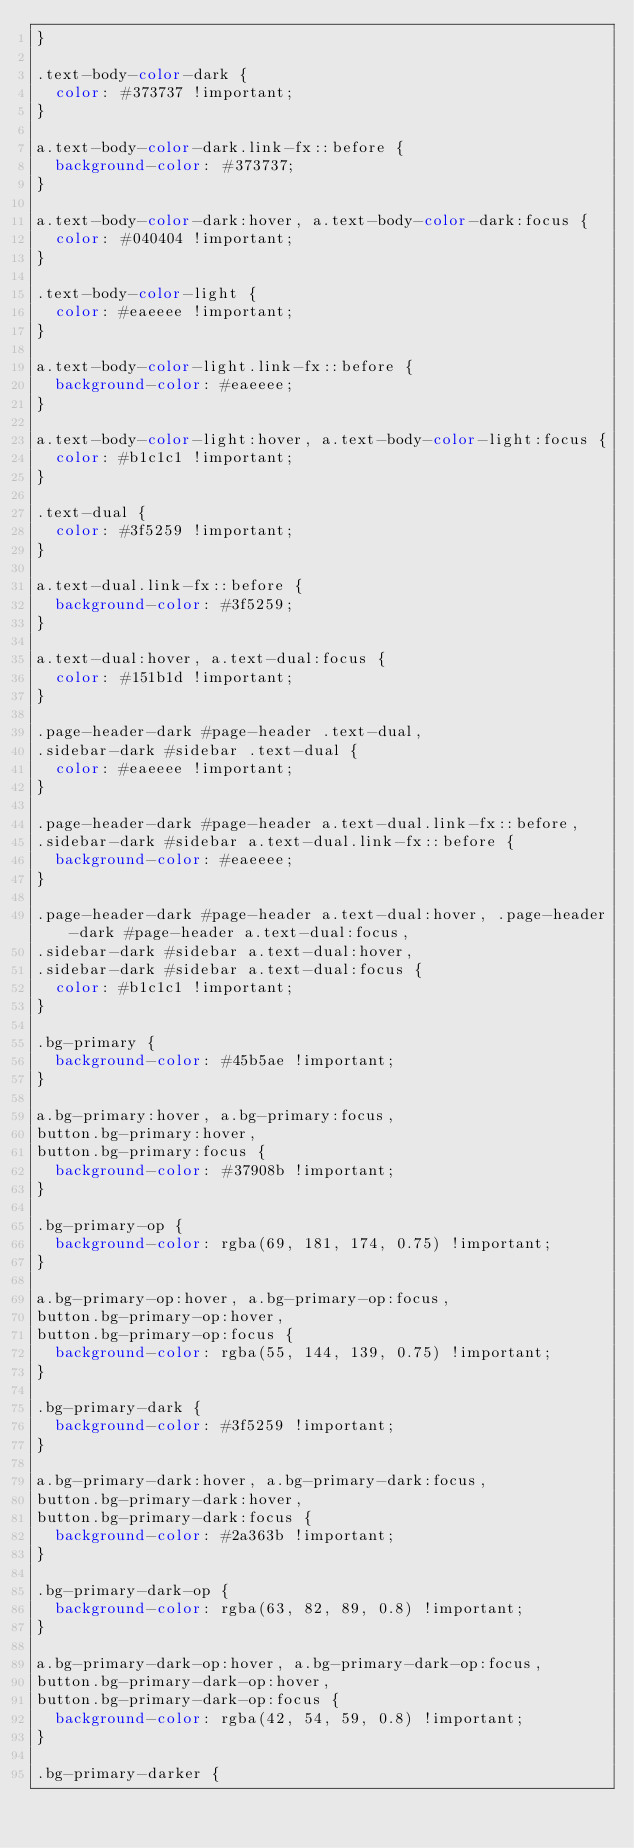Convert code to text. <code><loc_0><loc_0><loc_500><loc_500><_CSS_>}

.text-body-color-dark {
  color: #373737 !important;
}

a.text-body-color-dark.link-fx::before {
  background-color: #373737;
}

a.text-body-color-dark:hover, a.text-body-color-dark:focus {
  color: #040404 !important;
}

.text-body-color-light {
  color: #eaeeee !important;
}

a.text-body-color-light.link-fx::before {
  background-color: #eaeeee;
}

a.text-body-color-light:hover, a.text-body-color-light:focus {
  color: #b1c1c1 !important;
}

.text-dual {
  color: #3f5259 !important;
}

a.text-dual.link-fx::before {
  background-color: #3f5259;
}

a.text-dual:hover, a.text-dual:focus {
  color: #151b1d !important;
}

.page-header-dark #page-header .text-dual,
.sidebar-dark #sidebar .text-dual {
  color: #eaeeee !important;
}

.page-header-dark #page-header a.text-dual.link-fx::before,
.sidebar-dark #sidebar a.text-dual.link-fx::before {
  background-color: #eaeeee;
}

.page-header-dark #page-header a.text-dual:hover, .page-header-dark #page-header a.text-dual:focus,
.sidebar-dark #sidebar a.text-dual:hover,
.sidebar-dark #sidebar a.text-dual:focus {
  color: #b1c1c1 !important;
}

.bg-primary {
  background-color: #45b5ae !important;
}

a.bg-primary:hover, a.bg-primary:focus,
button.bg-primary:hover,
button.bg-primary:focus {
  background-color: #37908b !important;
}

.bg-primary-op {
  background-color: rgba(69, 181, 174, 0.75) !important;
}

a.bg-primary-op:hover, a.bg-primary-op:focus,
button.bg-primary-op:hover,
button.bg-primary-op:focus {
  background-color: rgba(55, 144, 139, 0.75) !important;
}

.bg-primary-dark {
  background-color: #3f5259 !important;
}

a.bg-primary-dark:hover, a.bg-primary-dark:focus,
button.bg-primary-dark:hover,
button.bg-primary-dark:focus {
  background-color: #2a363b !important;
}

.bg-primary-dark-op {
  background-color: rgba(63, 82, 89, 0.8) !important;
}

a.bg-primary-dark-op:hover, a.bg-primary-dark-op:focus,
button.bg-primary-dark-op:hover,
button.bg-primary-dark-op:focus {
  background-color: rgba(42, 54, 59, 0.8) !important;
}

.bg-primary-darker {</code> 